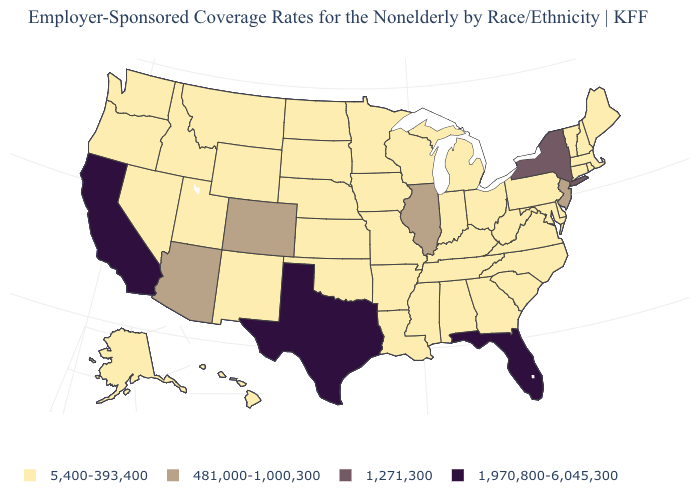Does Indiana have the lowest value in the USA?
Quick response, please. Yes. Which states have the highest value in the USA?
Concise answer only. California, Florida, Texas. What is the value of Nevada?
Keep it brief. 5,400-393,400. Name the states that have a value in the range 481,000-1,000,300?
Be succinct. Arizona, Colorado, Illinois, New Jersey. What is the highest value in the Northeast ?
Concise answer only. 1,271,300. Does Kentucky have the same value as Texas?
Answer briefly. No. What is the value of Oregon?
Keep it brief. 5,400-393,400. Name the states that have a value in the range 1,970,800-6,045,300?
Keep it brief. California, Florida, Texas. Name the states that have a value in the range 1,970,800-6,045,300?
Write a very short answer. California, Florida, Texas. Does California have the highest value in the USA?
Give a very brief answer. Yes. Which states have the lowest value in the USA?
Give a very brief answer. Alabama, Alaska, Arkansas, Connecticut, Delaware, Georgia, Hawaii, Idaho, Indiana, Iowa, Kansas, Kentucky, Louisiana, Maine, Maryland, Massachusetts, Michigan, Minnesota, Mississippi, Missouri, Montana, Nebraska, Nevada, New Hampshire, New Mexico, North Carolina, North Dakota, Ohio, Oklahoma, Oregon, Pennsylvania, Rhode Island, South Carolina, South Dakota, Tennessee, Utah, Vermont, Virginia, Washington, West Virginia, Wisconsin, Wyoming. How many symbols are there in the legend?
Give a very brief answer. 4. How many symbols are there in the legend?
Be succinct. 4. Name the states that have a value in the range 1,970,800-6,045,300?
Concise answer only. California, Florida, Texas. 